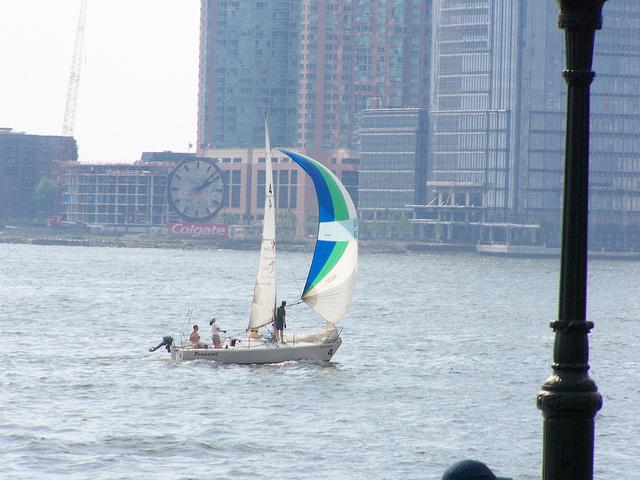What period of the day is shown here?

Choices:
A) morning
B) afternoon
C) evening
D) night afternoon 